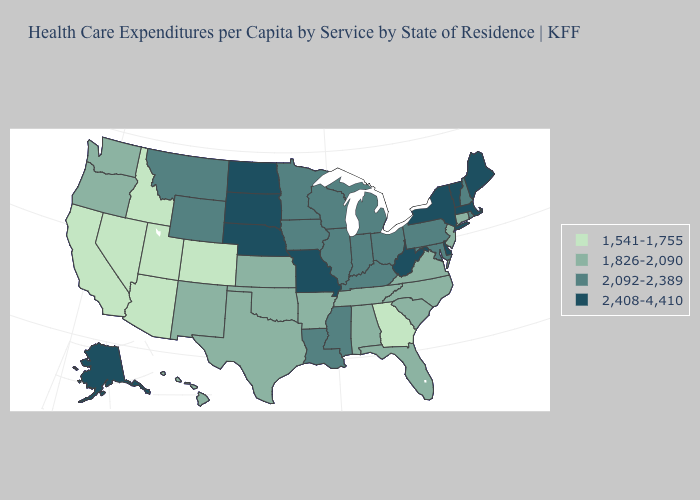Among the states that border Vermont , does New Hampshire have the lowest value?
Quick response, please. Yes. What is the highest value in the West ?
Concise answer only. 2,408-4,410. Does the first symbol in the legend represent the smallest category?
Answer briefly. Yes. Does Illinois have the lowest value in the MidWest?
Give a very brief answer. No. Name the states that have a value in the range 2,092-2,389?
Keep it brief. Illinois, Indiana, Iowa, Kentucky, Louisiana, Maryland, Michigan, Minnesota, Mississippi, Montana, New Hampshire, Ohio, Pennsylvania, Rhode Island, Wisconsin, Wyoming. What is the value of Oregon?
Quick response, please. 1,826-2,090. Name the states that have a value in the range 1,541-1,755?
Keep it brief. Arizona, California, Colorado, Georgia, Idaho, Nevada, Utah. Which states have the highest value in the USA?
Short answer required. Alaska, Delaware, Maine, Massachusetts, Missouri, Nebraska, New York, North Dakota, South Dakota, Vermont, West Virginia. Does North Dakota have the highest value in the USA?
Short answer required. Yes. Does New Mexico have the lowest value in the USA?
Answer briefly. No. Does Delaware have the highest value in the USA?
Give a very brief answer. Yes. Among the states that border Minnesota , does Wisconsin have the lowest value?
Be succinct. Yes. Does West Virginia have the highest value in the South?
Be succinct. Yes. Name the states that have a value in the range 2,408-4,410?
Answer briefly. Alaska, Delaware, Maine, Massachusetts, Missouri, Nebraska, New York, North Dakota, South Dakota, Vermont, West Virginia. Does North Dakota have a lower value than Georgia?
Give a very brief answer. No. 